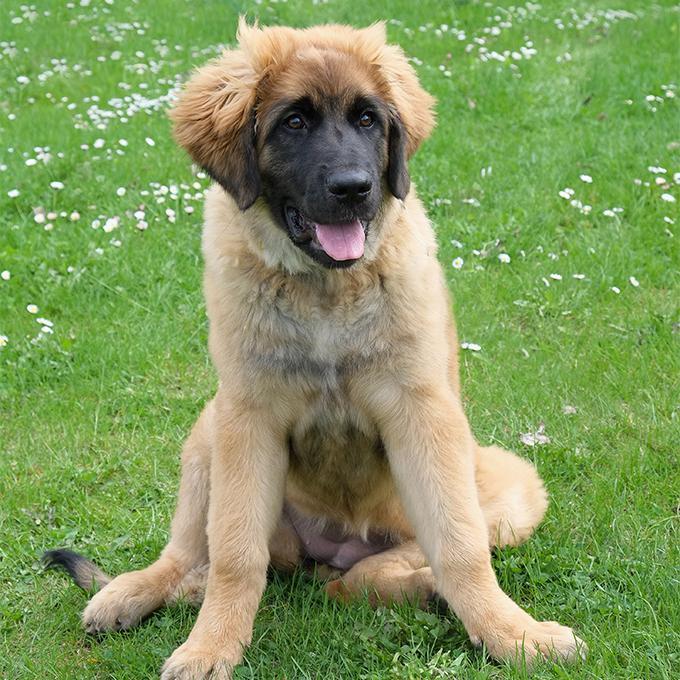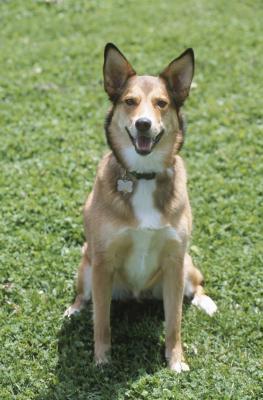The first image is the image on the left, the second image is the image on the right. Considering the images on both sides, is "There are a total of two dogs standing on all four legs." valid? Answer yes or no. No. 